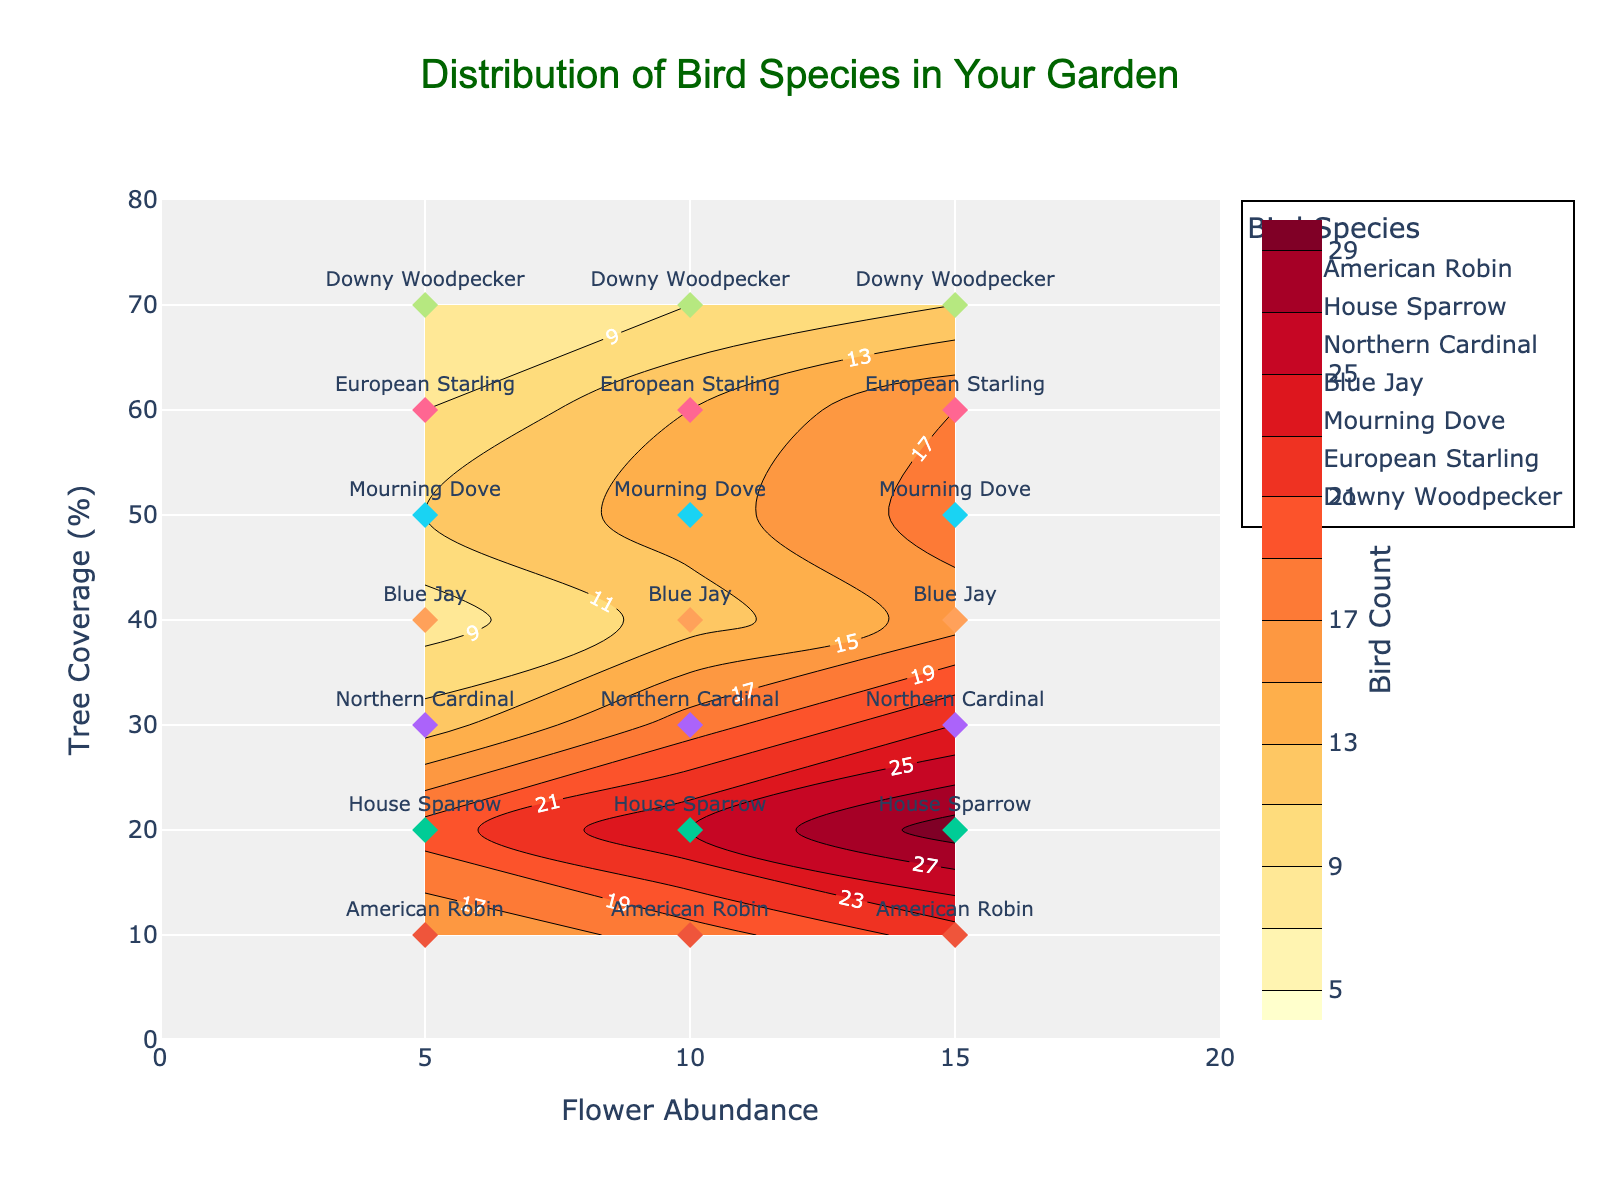What's the title of the plot? The title is written at the top center of the plot. It reads "Distribution of Bird Species in Your Garden".
Answer: Distribution of Bird Species in Your Garden Which bird species is labeled near the highest Tree Coverage and Flower Abundance values? The highest Tree Coverage is 70% and the highest Flower Abundance is 15. The bird species labeled at this point is "Downy Woodpecker".
Answer: Downy Woodpecker What is the range of the Flower Abundance values shown on the x-axis? Observing the x-axis, the range of Flower Abundance values extends from 0 to 20.
Answer: 0 to 20 Which bird species has the highest count at 10% Tree Coverage and 15 Flower Abundance? By examining the plot at the coordinates for 10% Tree Coverage and 15 Flower Abundance, the labeled bird species with the highest count is "American Robin".
Answer: American Robin How many bird species are present in the plot? There are multiple labels indicating different bird species. Counting the distinct labels: American Robin, House Sparrow, Northern Cardinal, Blue Jay, Mourning Dove, European Starling, and Downy Woodpecker, gives a total of 7 species.
Answer: 7 At which Tree Coverage level does the highest count for the Blue Jay occur? By examining the contour lines and labels, the highest count for Blue Jay occurs at a Tree Coverage of 40%.
Answer: 40% Is the bird count generally higher in areas with more Tree Coverage or Flower Abundance? Higher contour values, indicated by labels and color intensity, generally appear at higher Flower Abundance. This suggests a higher bird count correlated more strongly with higher Flower Abundance.
Answer: Higher Flower Abundance What is the average bird count for Northern Cardinal across all displayed values of Flower Abundance? For Northern Cardinal, the counts at 30% Tree Coverage are: 12, 18, and 23. Summing these (12 + 18 + 23) gives 53. Dividing by the number of data points (3) gives an average of 53/3 = 17.67.
Answer: 17.67 Compare the bird count differences between Blue Jay and Mourning Dove at 10 Flower Abundance and the same Tree Coverage levels. At 10 Flower Abundance, the bird counts at 40% Tree Coverage for Blue Jay is 12, and at 50% Tree Coverage for Mourning Dove is 14. The difference is 14 - 12 = 2.
Answer: 2 Which bird species is most evenly distributed across different levels of Tree Coverage and Flower Abundance? By looking at the number of points and their spread across the plot, the House Sparrow appears evenly distributed across multiple Flower Abundance levels (5, 10, 15) and Tree Coverage (20%).
Answer: House Sparrow 